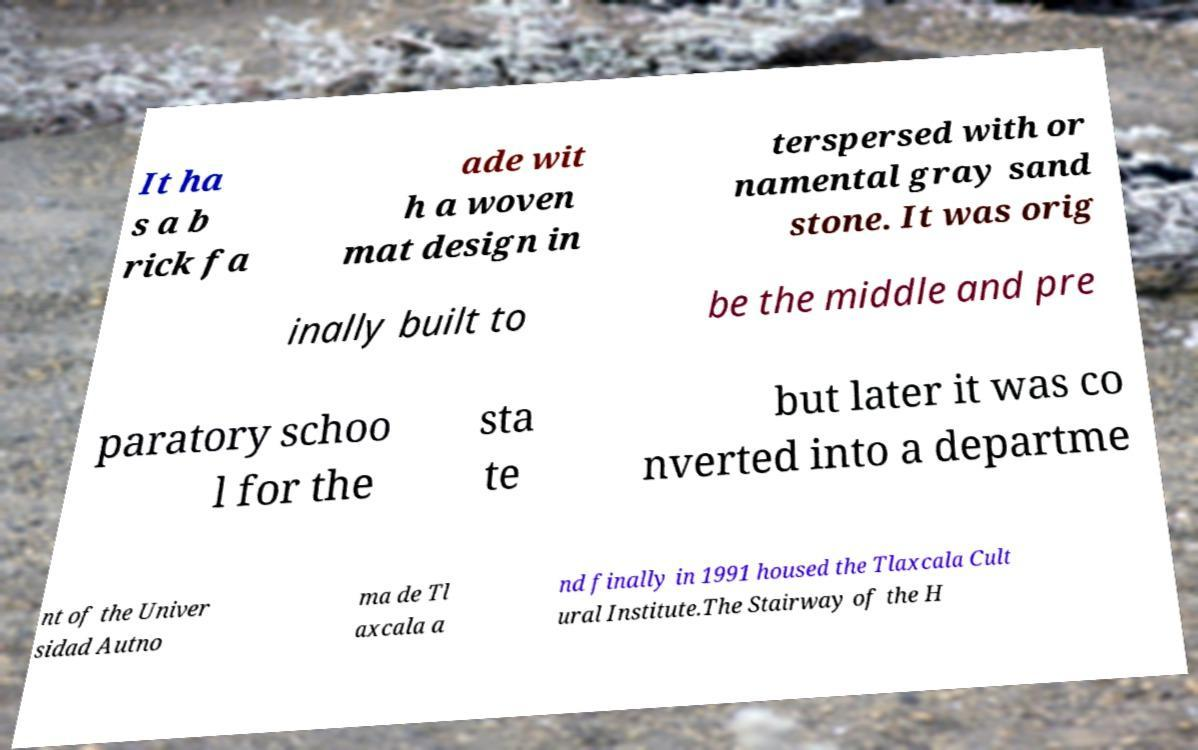For documentation purposes, I need the text within this image transcribed. Could you provide that? It ha s a b rick fa ade wit h a woven mat design in terspersed with or namental gray sand stone. It was orig inally built to be the middle and pre paratory schoo l for the sta te but later it was co nverted into a departme nt of the Univer sidad Autno ma de Tl axcala a nd finally in 1991 housed the Tlaxcala Cult ural Institute.The Stairway of the H 